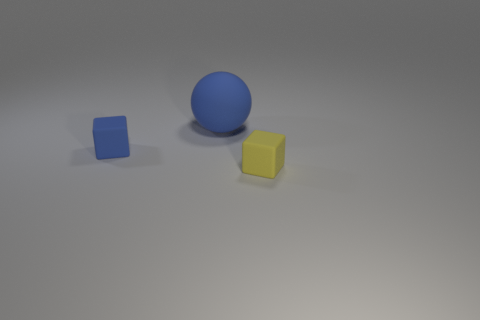Add 3 blue matte cubes. How many objects exist? 6 Subtract all spheres. How many objects are left? 2 Add 3 matte cubes. How many matte cubes exist? 5 Subtract 0 red spheres. How many objects are left? 3 Subtract all tiny yellow rubber blocks. Subtract all big balls. How many objects are left? 1 Add 1 small yellow rubber things. How many small yellow rubber things are left? 2 